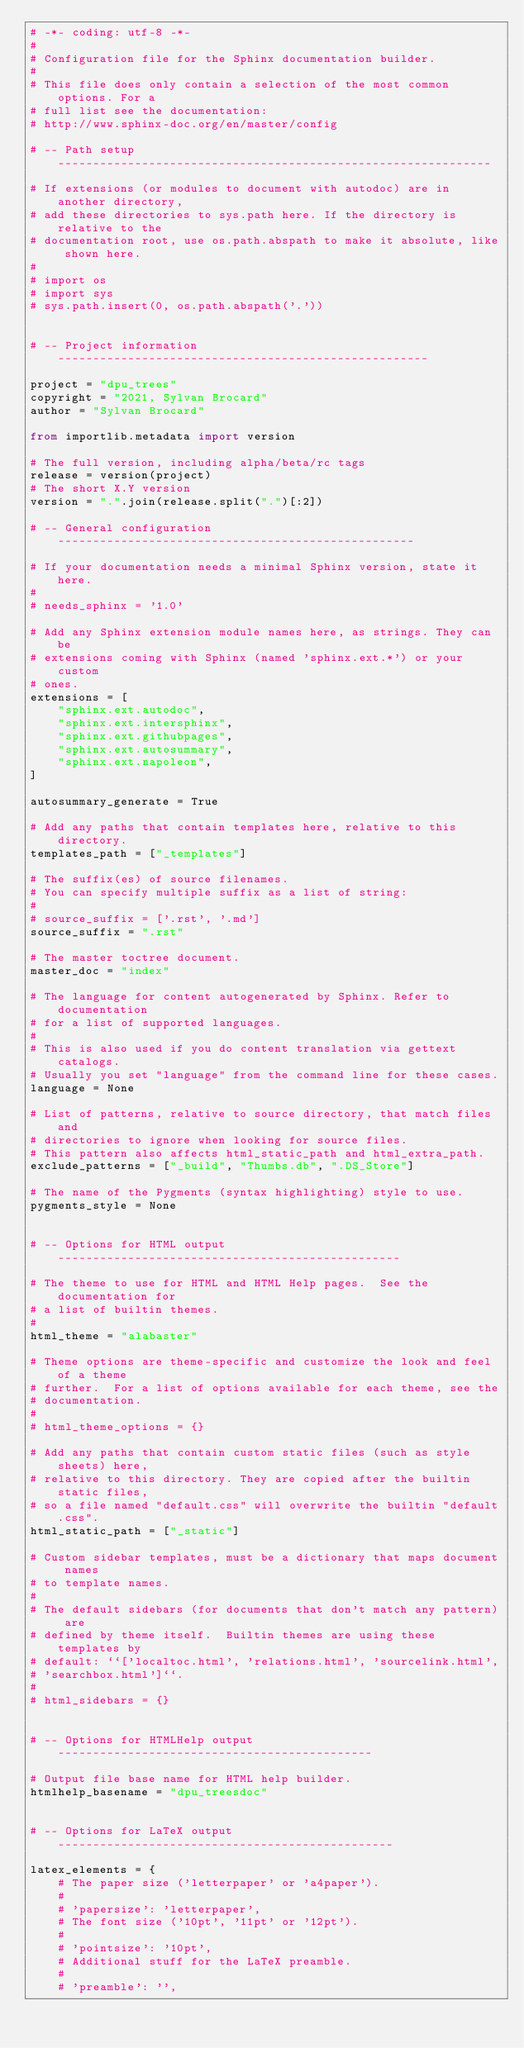Convert code to text. <code><loc_0><loc_0><loc_500><loc_500><_Python_># -*- coding: utf-8 -*-
#
# Configuration file for the Sphinx documentation builder.
#
# This file does only contain a selection of the most common options. For a
# full list see the documentation:
# http://www.sphinx-doc.org/en/master/config

# -- Path setup --------------------------------------------------------------

# If extensions (or modules to document with autodoc) are in another directory,
# add these directories to sys.path here. If the directory is relative to the
# documentation root, use os.path.abspath to make it absolute, like shown here.
#
# import os
# import sys
# sys.path.insert(0, os.path.abspath('.'))


# -- Project information -----------------------------------------------------

project = "dpu_trees"
copyright = "2021, Sylvan Brocard"
author = "Sylvan Brocard"

from importlib.metadata import version

# The full version, including alpha/beta/rc tags
release = version(project)
# The short X.Y version
version = ".".join(release.split(".")[:2])

# -- General configuration ---------------------------------------------------

# If your documentation needs a minimal Sphinx version, state it here.
#
# needs_sphinx = '1.0'

# Add any Sphinx extension module names here, as strings. They can be
# extensions coming with Sphinx (named 'sphinx.ext.*') or your custom
# ones.
extensions = [
    "sphinx.ext.autodoc",
    "sphinx.ext.intersphinx",
    "sphinx.ext.githubpages",
    "sphinx.ext.autosummary",
    "sphinx.ext.napoleon",
]

autosummary_generate = True

# Add any paths that contain templates here, relative to this directory.
templates_path = ["_templates"]

# The suffix(es) of source filenames.
# You can specify multiple suffix as a list of string:
#
# source_suffix = ['.rst', '.md']
source_suffix = ".rst"

# The master toctree document.
master_doc = "index"

# The language for content autogenerated by Sphinx. Refer to documentation
# for a list of supported languages.
#
# This is also used if you do content translation via gettext catalogs.
# Usually you set "language" from the command line for these cases.
language = None

# List of patterns, relative to source directory, that match files and
# directories to ignore when looking for source files.
# This pattern also affects html_static_path and html_extra_path.
exclude_patterns = ["_build", "Thumbs.db", ".DS_Store"]

# The name of the Pygments (syntax highlighting) style to use.
pygments_style = None


# -- Options for HTML output -------------------------------------------------

# The theme to use for HTML and HTML Help pages.  See the documentation for
# a list of builtin themes.
#
html_theme = "alabaster"

# Theme options are theme-specific and customize the look and feel of a theme
# further.  For a list of options available for each theme, see the
# documentation.
#
# html_theme_options = {}

# Add any paths that contain custom static files (such as style sheets) here,
# relative to this directory. They are copied after the builtin static files,
# so a file named "default.css" will overwrite the builtin "default.css".
html_static_path = ["_static"]

# Custom sidebar templates, must be a dictionary that maps document names
# to template names.
#
# The default sidebars (for documents that don't match any pattern) are
# defined by theme itself.  Builtin themes are using these templates by
# default: ``['localtoc.html', 'relations.html', 'sourcelink.html',
# 'searchbox.html']``.
#
# html_sidebars = {}


# -- Options for HTMLHelp output ---------------------------------------------

# Output file base name for HTML help builder.
htmlhelp_basename = "dpu_treesdoc"


# -- Options for LaTeX output ------------------------------------------------

latex_elements = {
    # The paper size ('letterpaper' or 'a4paper').
    #
    # 'papersize': 'letterpaper',
    # The font size ('10pt', '11pt' or '12pt').
    #
    # 'pointsize': '10pt',
    # Additional stuff for the LaTeX preamble.
    #
    # 'preamble': '',</code> 